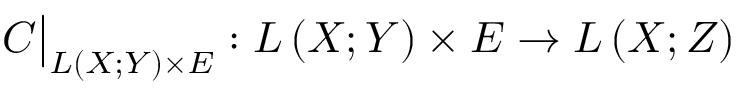<formula> <loc_0><loc_0><loc_500><loc_500>C { \Big | } _ { L \left ( X ; Y \right ) \times E } \colon L \left ( X ; Y \right ) \times E \to L \left ( X ; Z \right )</formula> 